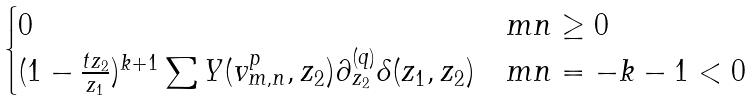<formula> <loc_0><loc_0><loc_500><loc_500>\begin{cases} 0 & m n \geq 0 \\ ( 1 - \frac { t { z _ { 2 } } } { z _ { 1 } } ) ^ { k + 1 } \sum Y ( v ^ { p } _ { m , n } , z _ { 2 } ) \partial _ { z _ { 2 } } ^ { ( q ) } \delta ( z _ { 1 } , z _ { 2 } ) & m n = - k - 1 < 0 \end{cases}</formula> 